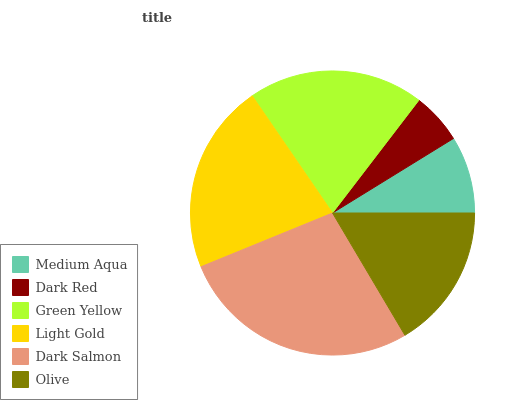Is Dark Red the minimum?
Answer yes or no. Yes. Is Dark Salmon the maximum?
Answer yes or no. Yes. Is Green Yellow the minimum?
Answer yes or no. No. Is Green Yellow the maximum?
Answer yes or no. No. Is Green Yellow greater than Dark Red?
Answer yes or no. Yes. Is Dark Red less than Green Yellow?
Answer yes or no. Yes. Is Dark Red greater than Green Yellow?
Answer yes or no. No. Is Green Yellow less than Dark Red?
Answer yes or no. No. Is Green Yellow the high median?
Answer yes or no. Yes. Is Olive the low median?
Answer yes or no. Yes. Is Dark Salmon the high median?
Answer yes or no. No. Is Medium Aqua the low median?
Answer yes or no. No. 